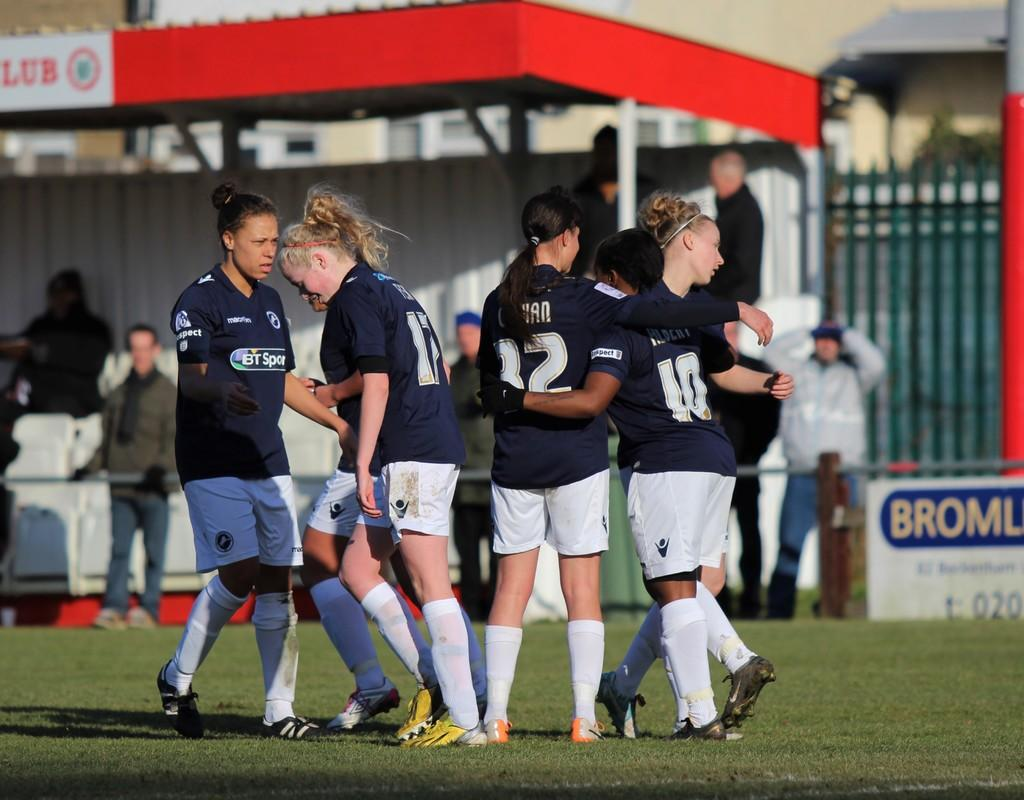Provide a one-sentence caption for the provided image. Player number 10 has her arm around another player's waist. 